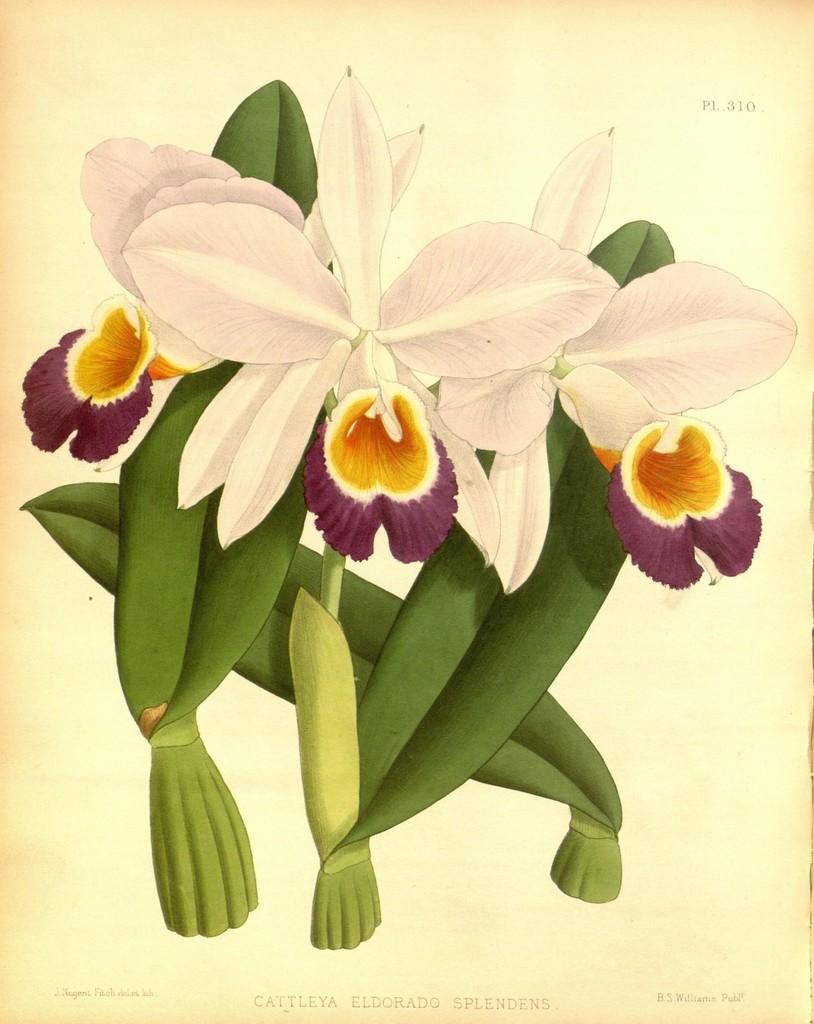Could you give a brief overview of what you see in this image? In the image we can see a flower painting. 